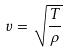<formula> <loc_0><loc_0><loc_500><loc_500>v = \sqrt { \frac { T } { \rho } }</formula> 